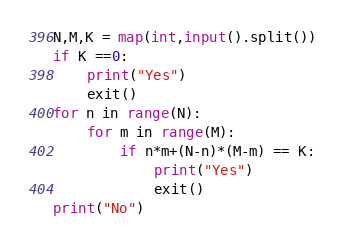Convert code to text. <code><loc_0><loc_0><loc_500><loc_500><_Python_>N,M,K = map(int,input().split())
if K ==0:
    print("Yes")
    exit()
for n in range(N):
    for m in range(M):
        if n*m+(N-n)*(M-m) == K:
            print("Yes")
            exit()
print("No")
</code> 